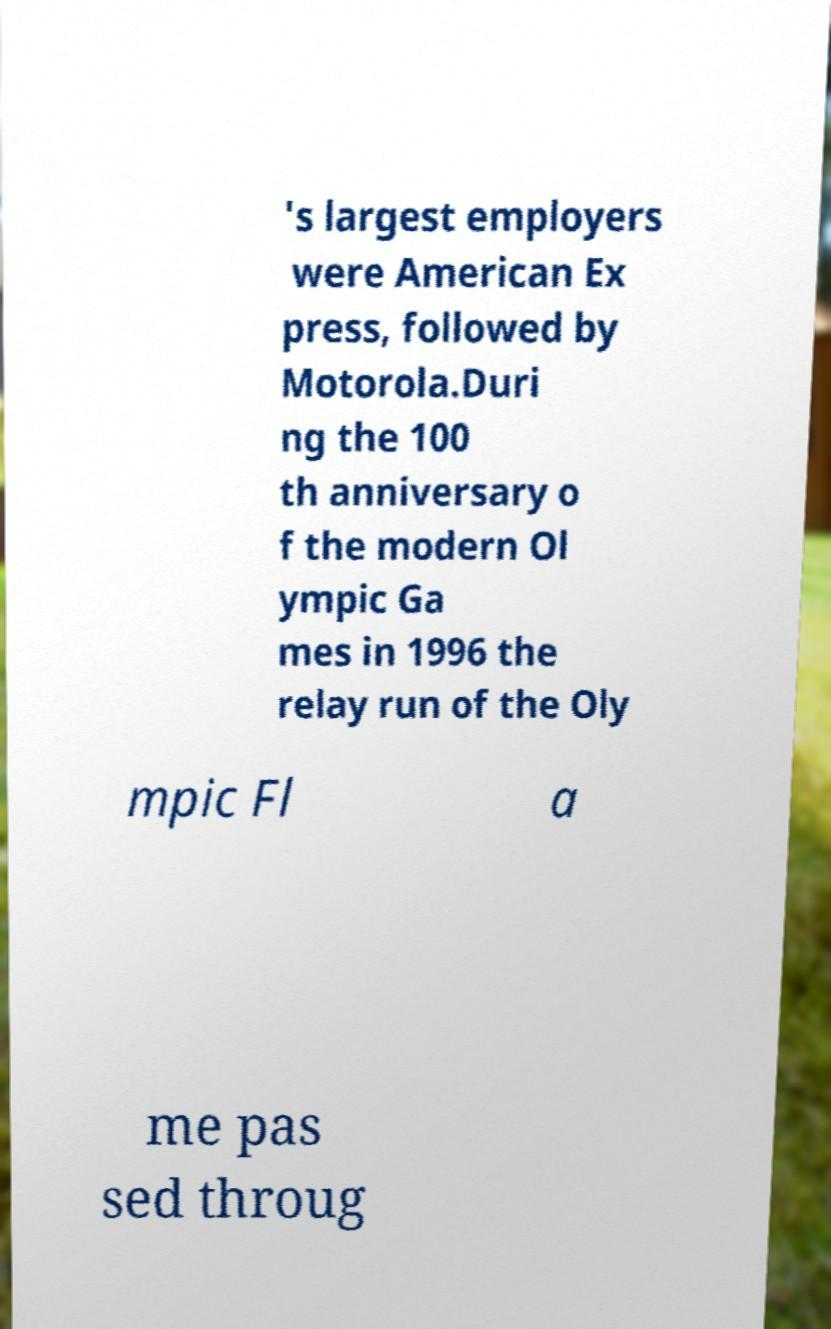I need the written content from this picture converted into text. Can you do that? 's largest employers were American Ex press, followed by Motorola.Duri ng the 100 th anniversary o f the modern Ol ympic Ga mes in 1996 the relay run of the Oly mpic Fl a me pas sed throug 